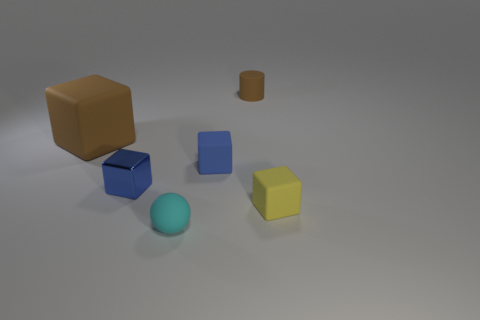There is a thing in front of the small yellow cube; does it have the same size as the brown rubber thing that is in front of the tiny brown rubber object?
Make the answer very short. No. There is a big matte thing to the left of the small blue object that is in front of the tiny blue matte object; are there any objects on the right side of it?
Offer a terse response. Yes. Are there fewer yellow things that are on the left side of the rubber sphere than yellow rubber cubes that are to the left of the tiny brown object?
Offer a terse response. No. There is a big thing that is the same material as the small sphere; what is its shape?
Your answer should be compact. Cube. There is a rubber cube that is on the left side of the small object in front of the matte thing that is on the right side of the tiny cylinder; what is its size?
Your answer should be compact. Large. Is the number of brown matte cubes greater than the number of blue rubber spheres?
Offer a very short reply. Yes. Does the rubber thing that is behind the large block have the same color as the matte block that is to the left of the sphere?
Offer a terse response. Yes. Does the ball to the left of the yellow matte object have the same material as the brown object on the left side of the tiny blue metal object?
Keep it short and to the point. Yes. What number of purple matte blocks have the same size as the cyan matte sphere?
Keep it short and to the point. 0. Is the number of gray rubber cylinders less than the number of large matte blocks?
Offer a terse response. Yes. 